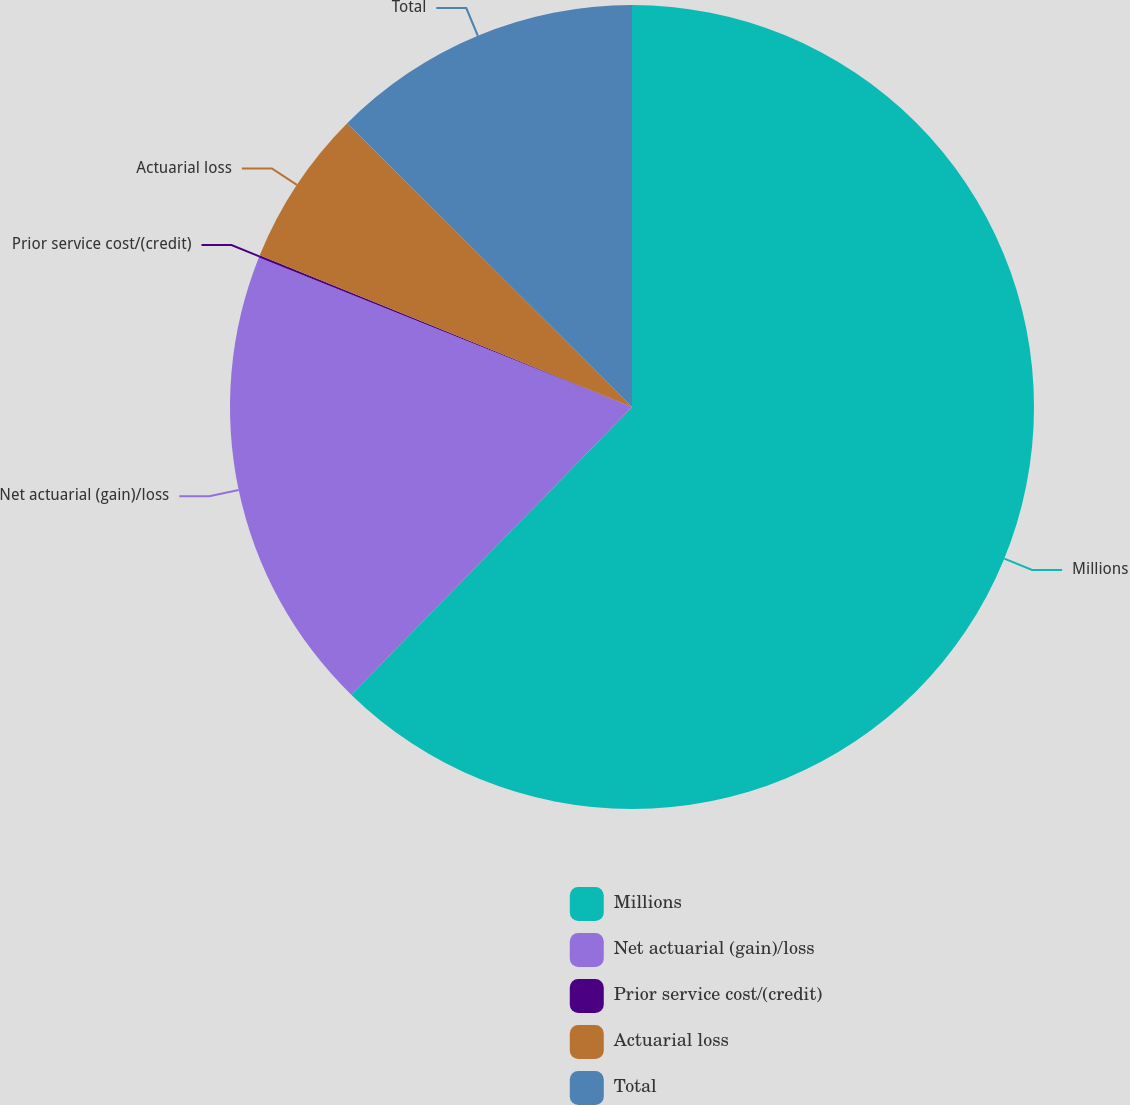Convert chart. <chart><loc_0><loc_0><loc_500><loc_500><pie_chart><fcel>Millions<fcel>Net actuarial (gain)/loss<fcel>Prior service cost/(credit)<fcel>Actuarial loss<fcel>Total<nl><fcel>62.3%<fcel>18.76%<fcel>0.09%<fcel>6.31%<fcel>12.53%<nl></chart> 